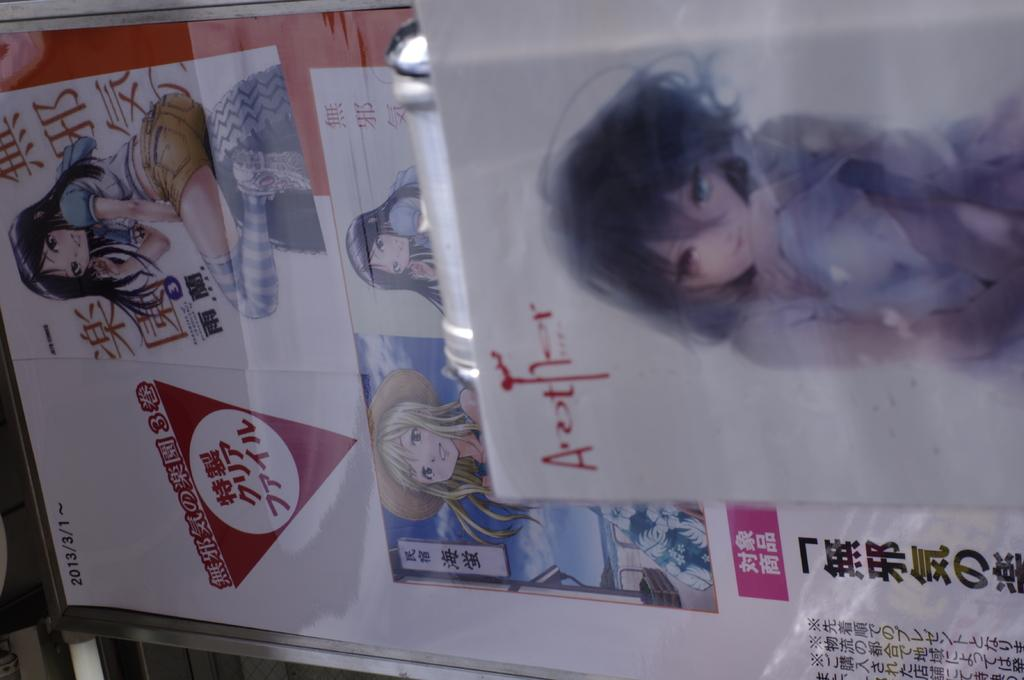What is present on the surface in the image? There are posters on the surface in the image. What can be seen on the posters? There are persons depicted on the posters, and there is text printed on the posters. Can you describe the object in the image? Unfortunately, the facts provided do not give any information about the object in the image. Can you tell me how many spies are swimming in the lake in the image? There is no lake or spies present in the image; it features posters with persons depicted on them. 